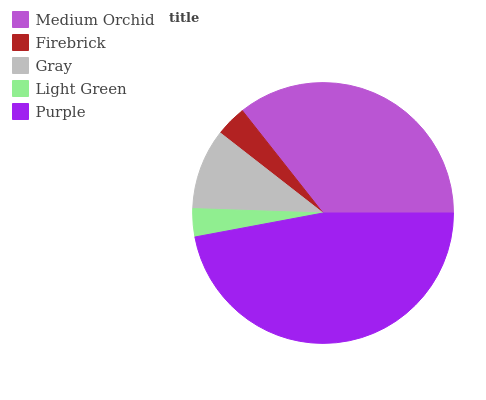Is Light Green the minimum?
Answer yes or no. Yes. Is Purple the maximum?
Answer yes or no. Yes. Is Firebrick the minimum?
Answer yes or no. No. Is Firebrick the maximum?
Answer yes or no. No. Is Medium Orchid greater than Firebrick?
Answer yes or no. Yes. Is Firebrick less than Medium Orchid?
Answer yes or no. Yes. Is Firebrick greater than Medium Orchid?
Answer yes or no. No. Is Medium Orchid less than Firebrick?
Answer yes or no. No. Is Gray the high median?
Answer yes or no. Yes. Is Gray the low median?
Answer yes or no. Yes. Is Purple the high median?
Answer yes or no. No. Is Medium Orchid the low median?
Answer yes or no. No. 